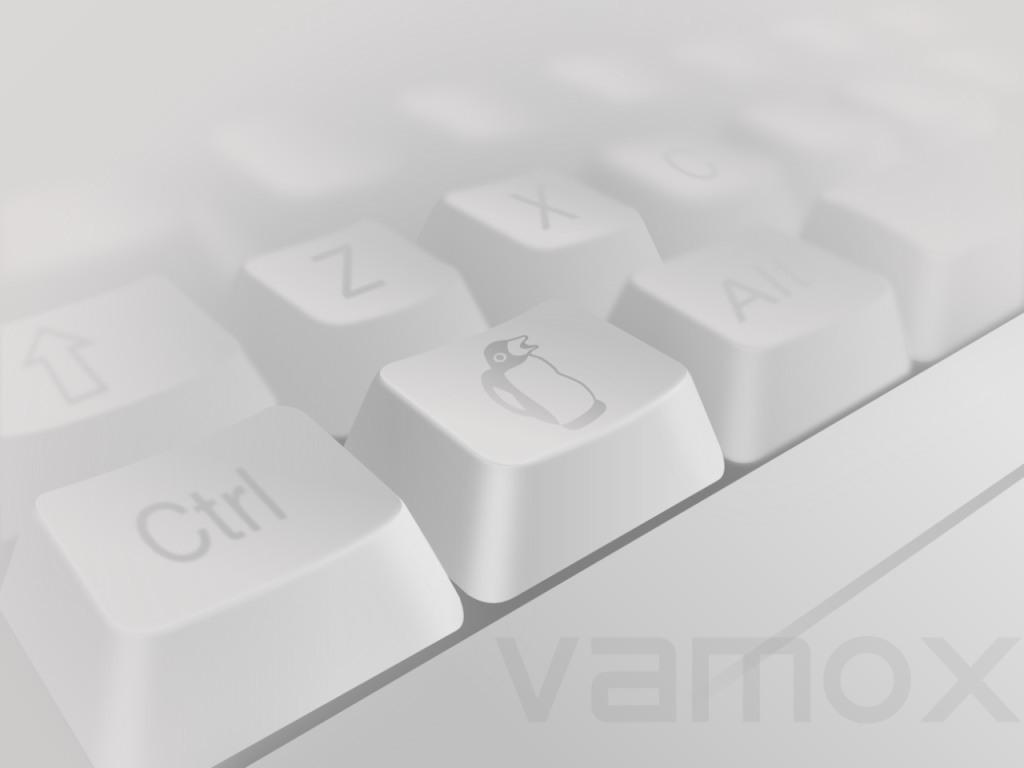Describe this image in one or two sentences. In the center of the image, we can see keys and at the bottom, there is some text. 